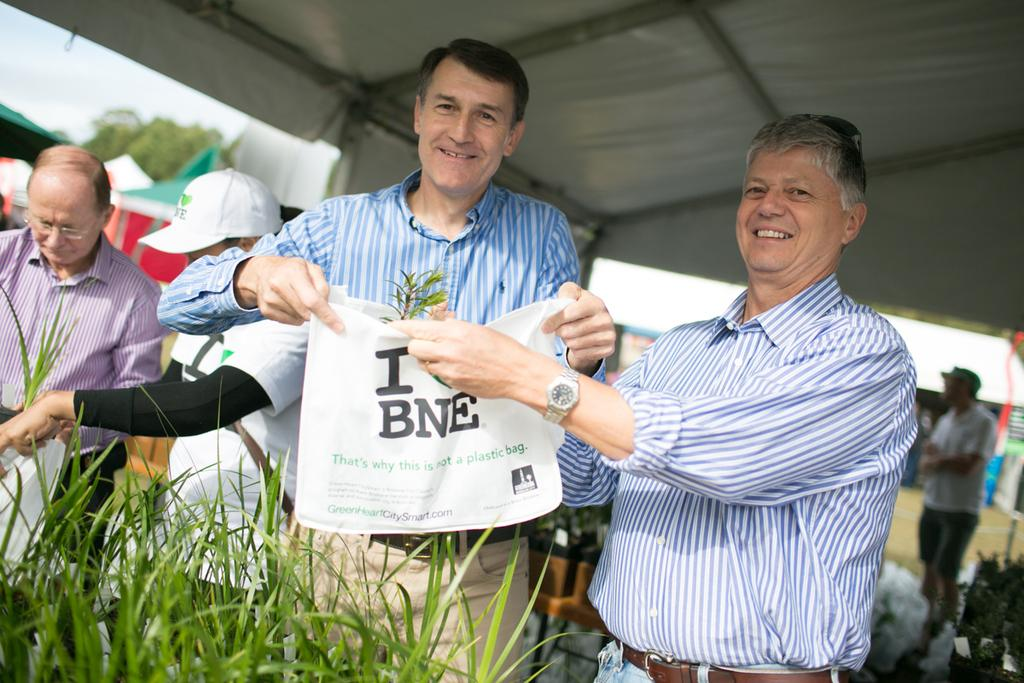How many people are the people are in the image? There is a group of people in the image, but the exact number cannot be determined from the provided facts. What can be seen in the background of the image? There are trees and tents in the background of the image. What is visible in the sky in the image? The sky is visible in the background of the image. What type of plant is being used as a rifle in the image? There is no plant or rifle present in the image. What type of plough is being used by the people in the image? There is no plough present in the image. 